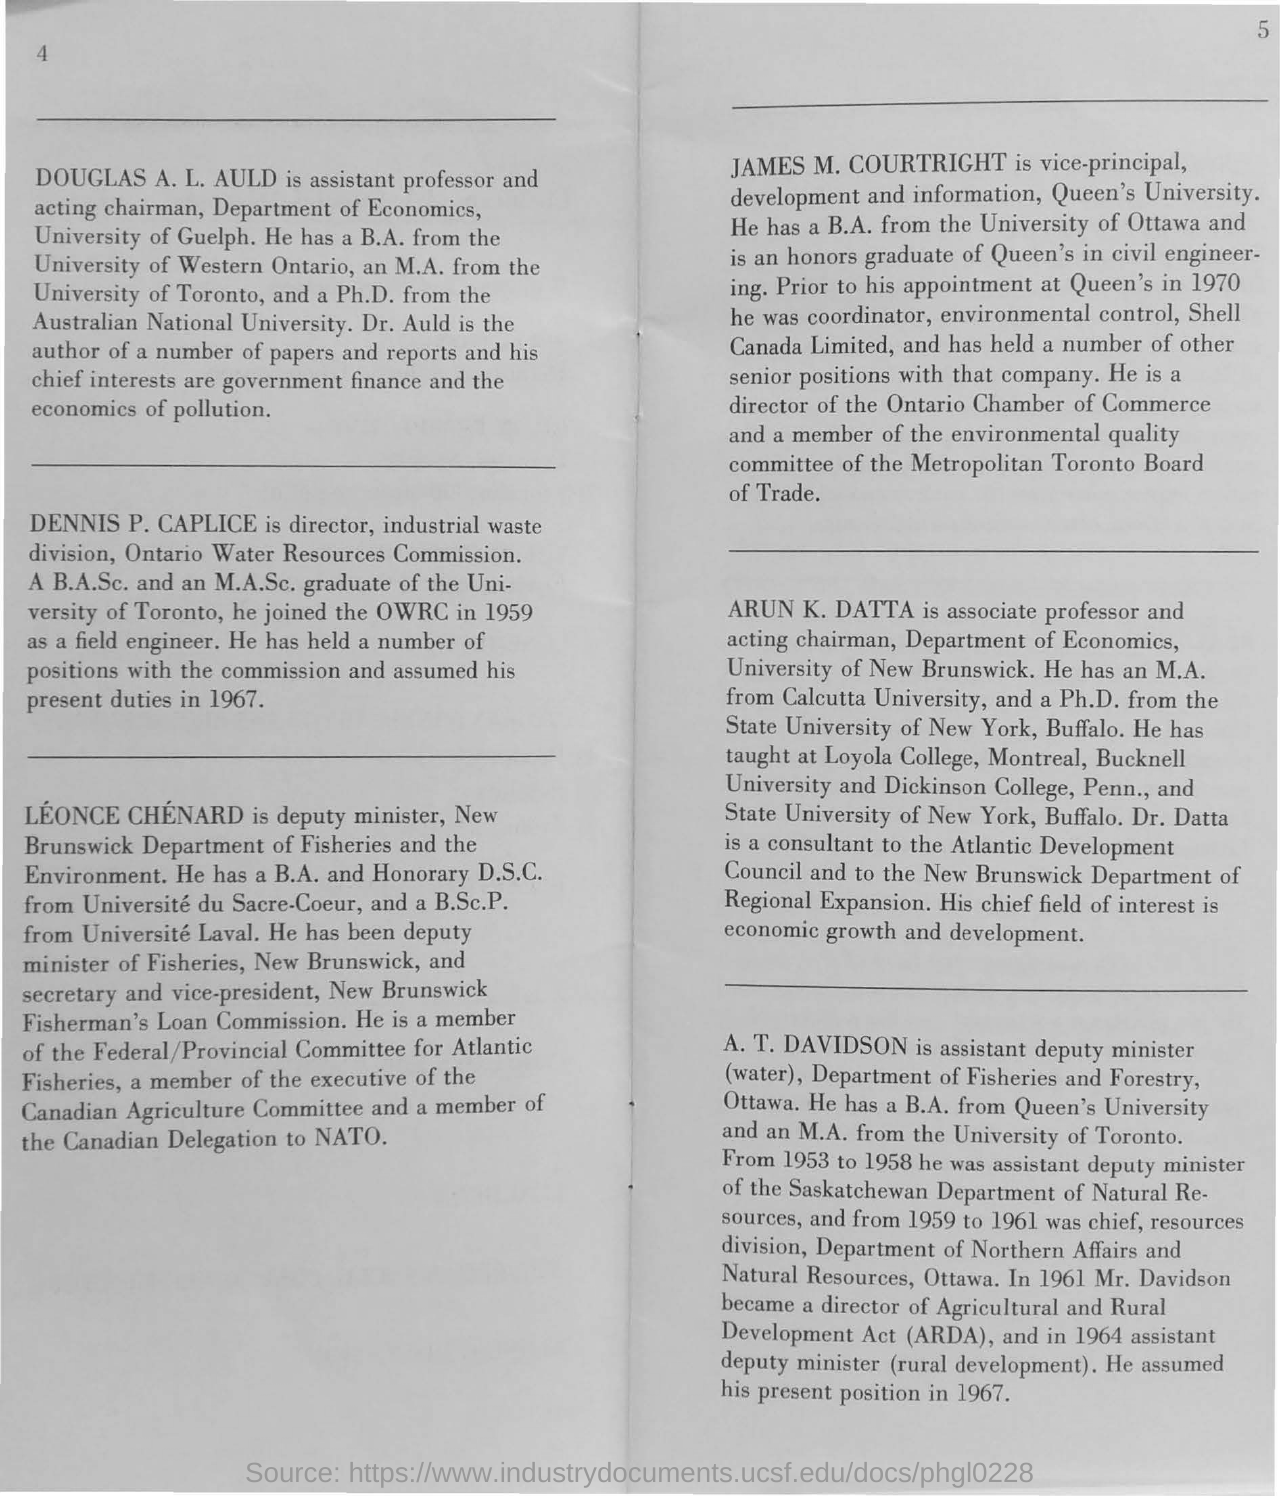Who is the assistant professor and acting chairman of University of Guelph?
Give a very brief answer. DOUGLAS A. L. AULD. What does ARDA stands for?
Ensure brevity in your answer.  Agricultural and Rural Development Act. 